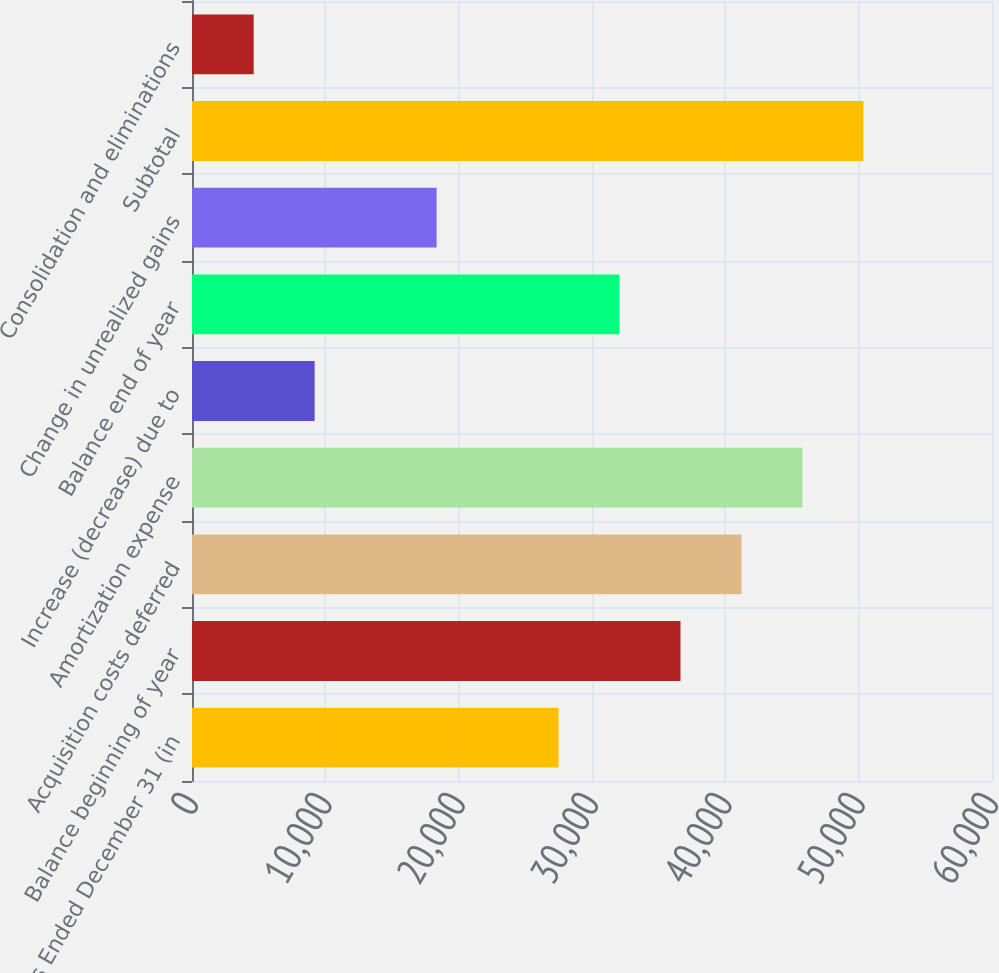Convert chart to OTSL. <chart><loc_0><loc_0><loc_500><loc_500><bar_chart><fcel>Years Ended December 31 (in<fcel>Balance beginning of year<fcel>Acquisition costs deferred<fcel>Amortization expense<fcel>Increase (decrease) due to<fcel>Balance end of year<fcel>Change in unrealized gains<fcel>Subtotal<fcel>Consolidation and eliminations<nl><fcel>27490.8<fcel>36636.4<fcel>41209.2<fcel>45782<fcel>9199.6<fcel>32063.6<fcel>18345.2<fcel>50354.8<fcel>4626.8<nl></chart> 